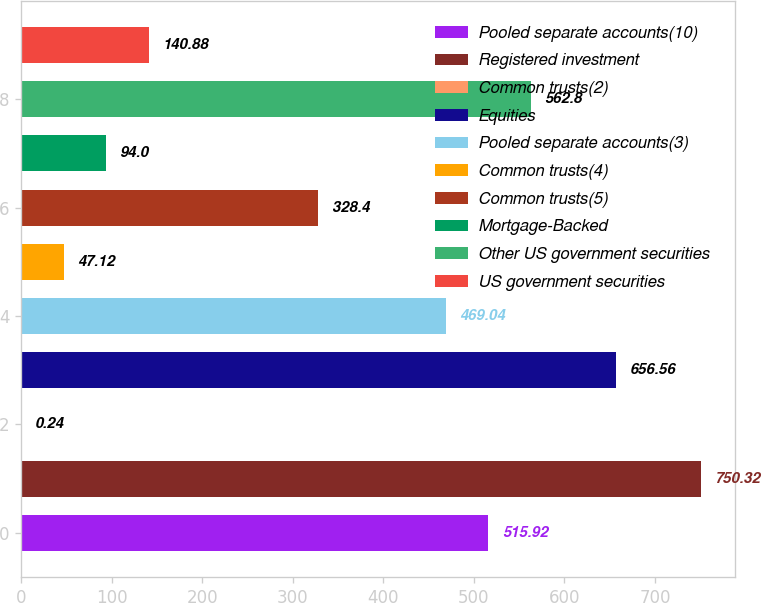Convert chart. <chart><loc_0><loc_0><loc_500><loc_500><bar_chart><fcel>Pooled separate accounts(10)<fcel>Registered investment<fcel>Common trusts(2)<fcel>Equities<fcel>Pooled separate accounts(3)<fcel>Common trusts(4)<fcel>Common trusts(5)<fcel>Mortgage-Backed<fcel>Other US government securities<fcel>US government securities<nl><fcel>515.92<fcel>750.32<fcel>0.24<fcel>656.56<fcel>469.04<fcel>47.12<fcel>328.4<fcel>94<fcel>562.8<fcel>140.88<nl></chart> 